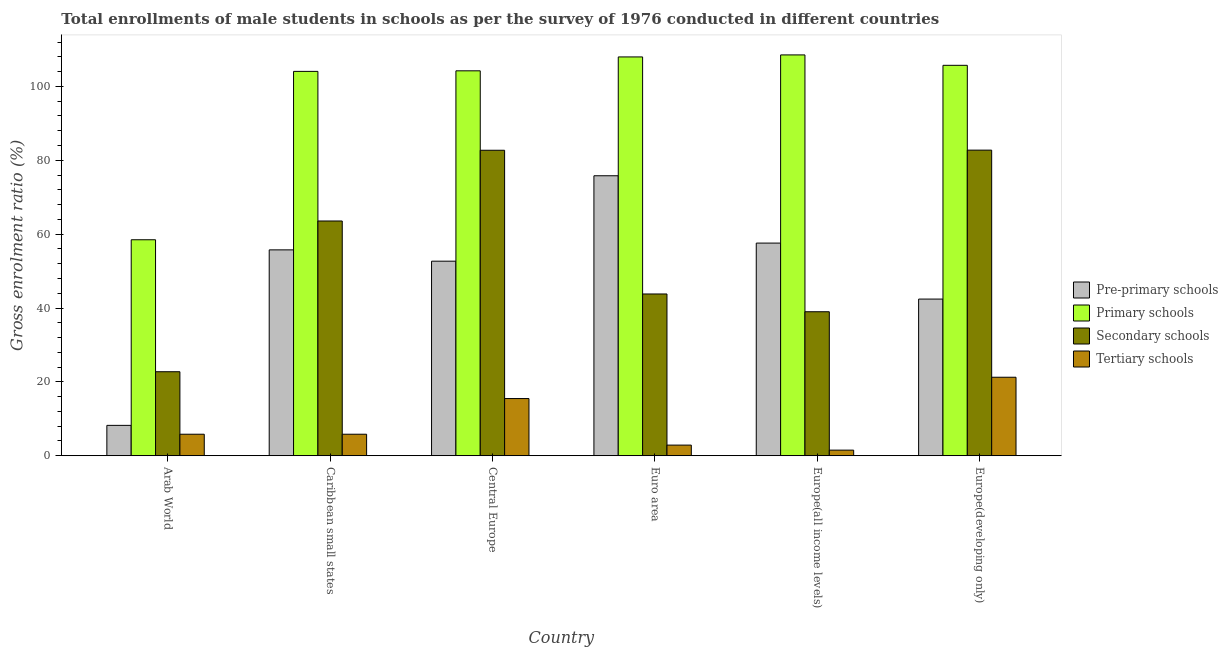How many different coloured bars are there?
Ensure brevity in your answer.  4. Are the number of bars on each tick of the X-axis equal?
Your answer should be compact. Yes. What is the label of the 2nd group of bars from the left?
Provide a succinct answer. Caribbean small states. What is the gross enrolment ratio(male) in pre-primary schools in Europe(all income levels)?
Your answer should be compact. 57.58. Across all countries, what is the maximum gross enrolment ratio(male) in primary schools?
Give a very brief answer. 108.53. Across all countries, what is the minimum gross enrolment ratio(male) in tertiary schools?
Provide a short and direct response. 1.52. In which country was the gross enrolment ratio(male) in pre-primary schools maximum?
Your response must be concise. Euro area. In which country was the gross enrolment ratio(male) in primary schools minimum?
Ensure brevity in your answer.  Arab World. What is the total gross enrolment ratio(male) in tertiary schools in the graph?
Provide a short and direct response. 52.77. What is the difference between the gross enrolment ratio(male) in secondary schools in Caribbean small states and that in Euro area?
Offer a terse response. 19.76. What is the difference between the gross enrolment ratio(male) in secondary schools in Euro area and the gross enrolment ratio(male) in tertiary schools in Europe(all income levels)?
Your answer should be very brief. 42.28. What is the average gross enrolment ratio(male) in pre-primary schools per country?
Your response must be concise. 48.74. What is the difference between the gross enrolment ratio(male) in pre-primary schools and gross enrolment ratio(male) in tertiary schools in Europe(all income levels)?
Keep it short and to the point. 56.06. In how many countries, is the gross enrolment ratio(male) in primary schools greater than 44 %?
Offer a terse response. 6. What is the ratio of the gross enrolment ratio(male) in primary schools in Arab World to that in Caribbean small states?
Provide a short and direct response. 0.56. What is the difference between the highest and the second highest gross enrolment ratio(male) in primary schools?
Give a very brief answer. 0.55. What is the difference between the highest and the lowest gross enrolment ratio(male) in tertiary schools?
Keep it short and to the point. 19.74. In how many countries, is the gross enrolment ratio(male) in pre-primary schools greater than the average gross enrolment ratio(male) in pre-primary schools taken over all countries?
Provide a succinct answer. 4. Is it the case that in every country, the sum of the gross enrolment ratio(male) in secondary schools and gross enrolment ratio(male) in tertiary schools is greater than the sum of gross enrolment ratio(male) in pre-primary schools and gross enrolment ratio(male) in primary schools?
Ensure brevity in your answer.  No. What does the 1st bar from the left in Central Europe represents?
Ensure brevity in your answer.  Pre-primary schools. What does the 3rd bar from the right in Central Europe represents?
Your response must be concise. Primary schools. Is it the case that in every country, the sum of the gross enrolment ratio(male) in pre-primary schools and gross enrolment ratio(male) in primary schools is greater than the gross enrolment ratio(male) in secondary schools?
Offer a terse response. Yes. How many bars are there?
Your answer should be compact. 24. Are all the bars in the graph horizontal?
Offer a terse response. No. How many countries are there in the graph?
Give a very brief answer. 6. Are the values on the major ticks of Y-axis written in scientific E-notation?
Provide a succinct answer. No. Where does the legend appear in the graph?
Ensure brevity in your answer.  Center right. What is the title of the graph?
Offer a terse response. Total enrollments of male students in schools as per the survey of 1976 conducted in different countries. What is the Gross enrolment ratio (%) in Pre-primary schools in Arab World?
Offer a terse response. 8.22. What is the Gross enrolment ratio (%) of Primary schools in Arab World?
Ensure brevity in your answer.  58.48. What is the Gross enrolment ratio (%) of Secondary schools in Arab World?
Provide a short and direct response. 22.75. What is the Gross enrolment ratio (%) in Tertiary schools in Arab World?
Offer a very short reply. 5.82. What is the Gross enrolment ratio (%) of Pre-primary schools in Caribbean small states?
Your answer should be very brief. 55.74. What is the Gross enrolment ratio (%) in Primary schools in Caribbean small states?
Ensure brevity in your answer.  104.08. What is the Gross enrolment ratio (%) in Secondary schools in Caribbean small states?
Provide a succinct answer. 63.56. What is the Gross enrolment ratio (%) of Tertiary schools in Caribbean small states?
Offer a very short reply. 5.82. What is the Gross enrolment ratio (%) of Pre-primary schools in Central Europe?
Provide a succinct answer. 52.68. What is the Gross enrolment ratio (%) in Primary schools in Central Europe?
Your response must be concise. 104.22. What is the Gross enrolment ratio (%) of Secondary schools in Central Europe?
Ensure brevity in your answer.  82.72. What is the Gross enrolment ratio (%) in Tertiary schools in Central Europe?
Keep it short and to the point. 15.48. What is the Gross enrolment ratio (%) of Pre-primary schools in Euro area?
Your answer should be compact. 75.81. What is the Gross enrolment ratio (%) in Primary schools in Euro area?
Ensure brevity in your answer.  107.99. What is the Gross enrolment ratio (%) of Secondary schools in Euro area?
Provide a succinct answer. 43.8. What is the Gross enrolment ratio (%) in Tertiary schools in Euro area?
Offer a terse response. 2.88. What is the Gross enrolment ratio (%) of Pre-primary schools in Europe(all income levels)?
Give a very brief answer. 57.58. What is the Gross enrolment ratio (%) in Primary schools in Europe(all income levels)?
Offer a terse response. 108.53. What is the Gross enrolment ratio (%) of Secondary schools in Europe(all income levels)?
Your answer should be very brief. 38.99. What is the Gross enrolment ratio (%) of Tertiary schools in Europe(all income levels)?
Keep it short and to the point. 1.52. What is the Gross enrolment ratio (%) in Pre-primary schools in Europe(developing only)?
Your response must be concise. 42.42. What is the Gross enrolment ratio (%) of Primary schools in Europe(developing only)?
Ensure brevity in your answer.  105.71. What is the Gross enrolment ratio (%) in Secondary schools in Europe(developing only)?
Ensure brevity in your answer.  82.75. What is the Gross enrolment ratio (%) of Tertiary schools in Europe(developing only)?
Keep it short and to the point. 21.25. Across all countries, what is the maximum Gross enrolment ratio (%) of Pre-primary schools?
Keep it short and to the point. 75.81. Across all countries, what is the maximum Gross enrolment ratio (%) of Primary schools?
Your response must be concise. 108.53. Across all countries, what is the maximum Gross enrolment ratio (%) in Secondary schools?
Offer a terse response. 82.75. Across all countries, what is the maximum Gross enrolment ratio (%) of Tertiary schools?
Provide a succinct answer. 21.25. Across all countries, what is the minimum Gross enrolment ratio (%) in Pre-primary schools?
Your answer should be compact. 8.22. Across all countries, what is the minimum Gross enrolment ratio (%) in Primary schools?
Provide a short and direct response. 58.48. Across all countries, what is the minimum Gross enrolment ratio (%) in Secondary schools?
Keep it short and to the point. 22.75. Across all countries, what is the minimum Gross enrolment ratio (%) in Tertiary schools?
Give a very brief answer. 1.52. What is the total Gross enrolment ratio (%) of Pre-primary schools in the graph?
Keep it short and to the point. 292.46. What is the total Gross enrolment ratio (%) in Primary schools in the graph?
Ensure brevity in your answer.  589.02. What is the total Gross enrolment ratio (%) of Secondary schools in the graph?
Your response must be concise. 334.56. What is the total Gross enrolment ratio (%) in Tertiary schools in the graph?
Give a very brief answer. 52.77. What is the difference between the Gross enrolment ratio (%) of Pre-primary schools in Arab World and that in Caribbean small states?
Make the answer very short. -47.52. What is the difference between the Gross enrolment ratio (%) of Primary schools in Arab World and that in Caribbean small states?
Offer a terse response. -45.59. What is the difference between the Gross enrolment ratio (%) of Secondary schools in Arab World and that in Caribbean small states?
Offer a terse response. -40.82. What is the difference between the Gross enrolment ratio (%) in Tertiary schools in Arab World and that in Caribbean small states?
Ensure brevity in your answer.  -0. What is the difference between the Gross enrolment ratio (%) of Pre-primary schools in Arab World and that in Central Europe?
Offer a very short reply. -44.46. What is the difference between the Gross enrolment ratio (%) of Primary schools in Arab World and that in Central Europe?
Make the answer very short. -45.74. What is the difference between the Gross enrolment ratio (%) of Secondary schools in Arab World and that in Central Europe?
Your response must be concise. -59.97. What is the difference between the Gross enrolment ratio (%) in Tertiary schools in Arab World and that in Central Europe?
Offer a very short reply. -9.66. What is the difference between the Gross enrolment ratio (%) in Pre-primary schools in Arab World and that in Euro area?
Ensure brevity in your answer.  -67.59. What is the difference between the Gross enrolment ratio (%) in Primary schools in Arab World and that in Euro area?
Your answer should be very brief. -49.5. What is the difference between the Gross enrolment ratio (%) of Secondary schools in Arab World and that in Euro area?
Your answer should be very brief. -21.05. What is the difference between the Gross enrolment ratio (%) in Tertiary schools in Arab World and that in Euro area?
Provide a succinct answer. 2.95. What is the difference between the Gross enrolment ratio (%) of Pre-primary schools in Arab World and that in Europe(all income levels)?
Give a very brief answer. -49.36. What is the difference between the Gross enrolment ratio (%) in Primary schools in Arab World and that in Europe(all income levels)?
Make the answer very short. -50.05. What is the difference between the Gross enrolment ratio (%) in Secondary schools in Arab World and that in Europe(all income levels)?
Ensure brevity in your answer.  -16.24. What is the difference between the Gross enrolment ratio (%) in Tertiary schools in Arab World and that in Europe(all income levels)?
Keep it short and to the point. 4.31. What is the difference between the Gross enrolment ratio (%) of Pre-primary schools in Arab World and that in Europe(developing only)?
Your response must be concise. -34.2. What is the difference between the Gross enrolment ratio (%) in Primary schools in Arab World and that in Europe(developing only)?
Give a very brief answer. -47.23. What is the difference between the Gross enrolment ratio (%) in Secondary schools in Arab World and that in Europe(developing only)?
Give a very brief answer. -60. What is the difference between the Gross enrolment ratio (%) of Tertiary schools in Arab World and that in Europe(developing only)?
Your answer should be very brief. -15.43. What is the difference between the Gross enrolment ratio (%) of Pre-primary schools in Caribbean small states and that in Central Europe?
Ensure brevity in your answer.  3.06. What is the difference between the Gross enrolment ratio (%) in Primary schools in Caribbean small states and that in Central Europe?
Provide a short and direct response. -0.15. What is the difference between the Gross enrolment ratio (%) in Secondary schools in Caribbean small states and that in Central Europe?
Provide a short and direct response. -19.15. What is the difference between the Gross enrolment ratio (%) in Tertiary schools in Caribbean small states and that in Central Europe?
Offer a very short reply. -9.66. What is the difference between the Gross enrolment ratio (%) of Pre-primary schools in Caribbean small states and that in Euro area?
Offer a very short reply. -20.07. What is the difference between the Gross enrolment ratio (%) of Primary schools in Caribbean small states and that in Euro area?
Your answer should be compact. -3.91. What is the difference between the Gross enrolment ratio (%) of Secondary schools in Caribbean small states and that in Euro area?
Ensure brevity in your answer.  19.76. What is the difference between the Gross enrolment ratio (%) of Tertiary schools in Caribbean small states and that in Euro area?
Offer a terse response. 2.95. What is the difference between the Gross enrolment ratio (%) in Pre-primary schools in Caribbean small states and that in Europe(all income levels)?
Give a very brief answer. -1.84. What is the difference between the Gross enrolment ratio (%) in Primary schools in Caribbean small states and that in Europe(all income levels)?
Make the answer very short. -4.46. What is the difference between the Gross enrolment ratio (%) in Secondary schools in Caribbean small states and that in Europe(all income levels)?
Give a very brief answer. 24.58. What is the difference between the Gross enrolment ratio (%) in Tertiary schools in Caribbean small states and that in Europe(all income levels)?
Offer a terse response. 4.31. What is the difference between the Gross enrolment ratio (%) in Pre-primary schools in Caribbean small states and that in Europe(developing only)?
Keep it short and to the point. 13.32. What is the difference between the Gross enrolment ratio (%) in Primary schools in Caribbean small states and that in Europe(developing only)?
Make the answer very short. -1.64. What is the difference between the Gross enrolment ratio (%) of Secondary schools in Caribbean small states and that in Europe(developing only)?
Offer a very short reply. -19.18. What is the difference between the Gross enrolment ratio (%) of Tertiary schools in Caribbean small states and that in Europe(developing only)?
Your answer should be very brief. -15.43. What is the difference between the Gross enrolment ratio (%) in Pre-primary schools in Central Europe and that in Euro area?
Ensure brevity in your answer.  -23.13. What is the difference between the Gross enrolment ratio (%) of Primary schools in Central Europe and that in Euro area?
Make the answer very short. -3.76. What is the difference between the Gross enrolment ratio (%) of Secondary schools in Central Europe and that in Euro area?
Offer a very short reply. 38.92. What is the difference between the Gross enrolment ratio (%) of Tertiary schools in Central Europe and that in Euro area?
Offer a terse response. 12.61. What is the difference between the Gross enrolment ratio (%) in Pre-primary schools in Central Europe and that in Europe(all income levels)?
Give a very brief answer. -4.9. What is the difference between the Gross enrolment ratio (%) of Primary schools in Central Europe and that in Europe(all income levels)?
Provide a short and direct response. -4.31. What is the difference between the Gross enrolment ratio (%) of Secondary schools in Central Europe and that in Europe(all income levels)?
Give a very brief answer. 43.73. What is the difference between the Gross enrolment ratio (%) of Tertiary schools in Central Europe and that in Europe(all income levels)?
Provide a short and direct response. 13.97. What is the difference between the Gross enrolment ratio (%) in Pre-primary schools in Central Europe and that in Europe(developing only)?
Give a very brief answer. 10.26. What is the difference between the Gross enrolment ratio (%) of Primary schools in Central Europe and that in Europe(developing only)?
Offer a terse response. -1.49. What is the difference between the Gross enrolment ratio (%) of Secondary schools in Central Europe and that in Europe(developing only)?
Make the answer very short. -0.03. What is the difference between the Gross enrolment ratio (%) in Tertiary schools in Central Europe and that in Europe(developing only)?
Make the answer very short. -5.77. What is the difference between the Gross enrolment ratio (%) in Pre-primary schools in Euro area and that in Europe(all income levels)?
Keep it short and to the point. 18.23. What is the difference between the Gross enrolment ratio (%) in Primary schools in Euro area and that in Europe(all income levels)?
Offer a very short reply. -0.55. What is the difference between the Gross enrolment ratio (%) of Secondary schools in Euro area and that in Europe(all income levels)?
Make the answer very short. 4.81. What is the difference between the Gross enrolment ratio (%) in Tertiary schools in Euro area and that in Europe(all income levels)?
Make the answer very short. 1.36. What is the difference between the Gross enrolment ratio (%) of Pre-primary schools in Euro area and that in Europe(developing only)?
Keep it short and to the point. 33.39. What is the difference between the Gross enrolment ratio (%) of Primary schools in Euro area and that in Europe(developing only)?
Your answer should be very brief. 2.27. What is the difference between the Gross enrolment ratio (%) of Secondary schools in Euro area and that in Europe(developing only)?
Give a very brief answer. -38.95. What is the difference between the Gross enrolment ratio (%) in Tertiary schools in Euro area and that in Europe(developing only)?
Provide a succinct answer. -18.38. What is the difference between the Gross enrolment ratio (%) of Pre-primary schools in Europe(all income levels) and that in Europe(developing only)?
Give a very brief answer. 15.16. What is the difference between the Gross enrolment ratio (%) in Primary schools in Europe(all income levels) and that in Europe(developing only)?
Ensure brevity in your answer.  2.82. What is the difference between the Gross enrolment ratio (%) in Secondary schools in Europe(all income levels) and that in Europe(developing only)?
Your answer should be compact. -43.76. What is the difference between the Gross enrolment ratio (%) in Tertiary schools in Europe(all income levels) and that in Europe(developing only)?
Your answer should be very brief. -19.74. What is the difference between the Gross enrolment ratio (%) of Pre-primary schools in Arab World and the Gross enrolment ratio (%) of Primary schools in Caribbean small states?
Provide a succinct answer. -95.85. What is the difference between the Gross enrolment ratio (%) in Pre-primary schools in Arab World and the Gross enrolment ratio (%) in Secondary schools in Caribbean small states?
Provide a succinct answer. -55.34. What is the difference between the Gross enrolment ratio (%) in Pre-primary schools in Arab World and the Gross enrolment ratio (%) in Tertiary schools in Caribbean small states?
Make the answer very short. 2.4. What is the difference between the Gross enrolment ratio (%) of Primary schools in Arab World and the Gross enrolment ratio (%) of Secondary schools in Caribbean small states?
Keep it short and to the point. -5.08. What is the difference between the Gross enrolment ratio (%) in Primary schools in Arab World and the Gross enrolment ratio (%) in Tertiary schools in Caribbean small states?
Your response must be concise. 52.66. What is the difference between the Gross enrolment ratio (%) in Secondary schools in Arab World and the Gross enrolment ratio (%) in Tertiary schools in Caribbean small states?
Your answer should be very brief. 16.92. What is the difference between the Gross enrolment ratio (%) of Pre-primary schools in Arab World and the Gross enrolment ratio (%) of Primary schools in Central Europe?
Offer a terse response. -96. What is the difference between the Gross enrolment ratio (%) of Pre-primary schools in Arab World and the Gross enrolment ratio (%) of Secondary schools in Central Europe?
Offer a very short reply. -74.49. What is the difference between the Gross enrolment ratio (%) of Pre-primary schools in Arab World and the Gross enrolment ratio (%) of Tertiary schools in Central Europe?
Offer a very short reply. -7.26. What is the difference between the Gross enrolment ratio (%) of Primary schools in Arab World and the Gross enrolment ratio (%) of Secondary schools in Central Europe?
Your response must be concise. -24.23. What is the difference between the Gross enrolment ratio (%) in Primary schools in Arab World and the Gross enrolment ratio (%) in Tertiary schools in Central Europe?
Ensure brevity in your answer.  43. What is the difference between the Gross enrolment ratio (%) in Secondary schools in Arab World and the Gross enrolment ratio (%) in Tertiary schools in Central Europe?
Your answer should be compact. 7.26. What is the difference between the Gross enrolment ratio (%) of Pre-primary schools in Arab World and the Gross enrolment ratio (%) of Primary schools in Euro area?
Your answer should be very brief. -99.77. What is the difference between the Gross enrolment ratio (%) in Pre-primary schools in Arab World and the Gross enrolment ratio (%) in Secondary schools in Euro area?
Provide a succinct answer. -35.58. What is the difference between the Gross enrolment ratio (%) in Pre-primary schools in Arab World and the Gross enrolment ratio (%) in Tertiary schools in Euro area?
Offer a terse response. 5.35. What is the difference between the Gross enrolment ratio (%) of Primary schools in Arab World and the Gross enrolment ratio (%) of Secondary schools in Euro area?
Your answer should be compact. 14.68. What is the difference between the Gross enrolment ratio (%) of Primary schools in Arab World and the Gross enrolment ratio (%) of Tertiary schools in Euro area?
Your answer should be very brief. 55.61. What is the difference between the Gross enrolment ratio (%) of Secondary schools in Arab World and the Gross enrolment ratio (%) of Tertiary schools in Euro area?
Offer a terse response. 19.87. What is the difference between the Gross enrolment ratio (%) in Pre-primary schools in Arab World and the Gross enrolment ratio (%) in Primary schools in Europe(all income levels)?
Ensure brevity in your answer.  -100.31. What is the difference between the Gross enrolment ratio (%) in Pre-primary schools in Arab World and the Gross enrolment ratio (%) in Secondary schools in Europe(all income levels)?
Your response must be concise. -30.77. What is the difference between the Gross enrolment ratio (%) of Pre-primary schools in Arab World and the Gross enrolment ratio (%) of Tertiary schools in Europe(all income levels)?
Your answer should be compact. 6.71. What is the difference between the Gross enrolment ratio (%) in Primary schools in Arab World and the Gross enrolment ratio (%) in Secondary schools in Europe(all income levels)?
Ensure brevity in your answer.  19.5. What is the difference between the Gross enrolment ratio (%) of Primary schools in Arab World and the Gross enrolment ratio (%) of Tertiary schools in Europe(all income levels)?
Give a very brief answer. 56.97. What is the difference between the Gross enrolment ratio (%) of Secondary schools in Arab World and the Gross enrolment ratio (%) of Tertiary schools in Europe(all income levels)?
Keep it short and to the point. 21.23. What is the difference between the Gross enrolment ratio (%) in Pre-primary schools in Arab World and the Gross enrolment ratio (%) in Primary schools in Europe(developing only)?
Provide a short and direct response. -97.49. What is the difference between the Gross enrolment ratio (%) in Pre-primary schools in Arab World and the Gross enrolment ratio (%) in Secondary schools in Europe(developing only)?
Your response must be concise. -74.53. What is the difference between the Gross enrolment ratio (%) in Pre-primary schools in Arab World and the Gross enrolment ratio (%) in Tertiary schools in Europe(developing only)?
Your answer should be compact. -13.03. What is the difference between the Gross enrolment ratio (%) in Primary schools in Arab World and the Gross enrolment ratio (%) in Secondary schools in Europe(developing only)?
Offer a very short reply. -24.27. What is the difference between the Gross enrolment ratio (%) of Primary schools in Arab World and the Gross enrolment ratio (%) of Tertiary schools in Europe(developing only)?
Provide a short and direct response. 37.23. What is the difference between the Gross enrolment ratio (%) in Secondary schools in Arab World and the Gross enrolment ratio (%) in Tertiary schools in Europe(developing only)?
Keep it short and to the point. 1.49. What is the difference between the Gross enrolment ratio (%) of Pre-primary schools in Caribbean small states and the Gross enrolment ratio (%) of Primary schools in Central Europe?
Keep it short and to the point. -48.48. What is the difference between the Gross enrolment ratio (%) in Pre-primary schools in Caribbean small states and the Gross enrolment ratio (%) in Secondary schools in Central Europe?
Make the answer very short. -26.97. What is the difference between the Gross enrolment ratio (%) in Pre-primary schools in Caribbean small states and the Gross enrolment ratio (%) in Tertiary schools in Central Europe?
Provide a succinct answer. 40.26. What is the difference between the Gross enrolment ratio (%) of Primary schools in Caribbean small states and the Gross enrolment ratio (%) of Secondary schools in Central Europe?
Ensure brevity in your answer.  21.36. What is the difference between the Gross enrolment ratio (%) of Primary schools in Caribbean small states and the Gross enrolment ratio (%) of Tertiary schools in Central Europe?
Offer a very short reply. 88.59. What is the difference between the Gross enrolment ratio (%) in Secondary schools in Caribbean small states and the Gross enrolment ratio (%) in Tertiary schools in Central Europe?
Provide a short and direct response. 48.08. What is the difference between the Gross enrolment ratio (%) of Pre-primary schools in Caribbean small states and the Gross enrolment ratio (%) of Primary schools in Euro area?
Make the answer very short. -52.24. What is the difference between the Gross enrolment ratio (%) in Pre-primary schools in Caribbean small states and the Gross enrolment ratio (%) in Secondary schools in Euro area?
Provide a short and direct response. 11.94. What is the difference between the Gross enrolment ratio (%) in Pre-primary schools in Caribbean small states and the Gross enrolment ratio (%) in Tertiary schools in Euro area?
Offer a terse response. 52.87. What is the difference between the Gross enrolment ratio (%) in Primary schools in Caribbean small states and the Gross enrolment ratio (%) in Secondary schools in Euro area?
Ensure brevity in your answer.  60.28. What is the difference between the Gross enrolment ratio (%) in Primary schools in Caribbean small states and the Gross enrolment ratio (%) in Tertiary schools in Euro area?
Your response must be concise. 101.2. What is the difference between the Gross enrolment ratio (%) in Secondary schools in Caribbean small states and the Gross enrolment ratio (%) in Tertiary schools in Euro area?
Keep it short and to the point. 60.69. What is the difference between the Gross enrolment ratio (%) of Pre-primary schools in Caribbean small states and the Gross enrolment ratio (%) of Primary schools in Europe(all income levels)?
Offer a terse response. -52.79. What is the difference between the Gross enrolment ratio (%) in Pre-primary schools in Caribbean small states and the Gross enrolment ratio (%) in Secondary schools in Europe(all income levels)?
Keep it short and to the point. 16.76. What is the difference between the Gross enrolment ratio (%) of Pre-primary schools in Caribbean small states and the Gross enrolment ratio (%) of Tertiary schools in Europe(all income levels)?
Ensure brevity in your answer.  54.23. What is the difference between the Gross enrolment ratio (%) of Primary schools in Caribbean small states and the Gross enrolment ratio (%) of Secondary schools in Europe(all income levels)?
Provide a short and direct response. 65.09. What is the difference between the Gross enrolment ratio (%) of Primary schools in Caribbean small states and the Gross enrolment ratio (%) of Tertiary schools in Europe(all income levels)?
Provide a short and direct response. 102.56. What is the difference between the Gross enrolment ratio (%) in Secondary schools in Caribbean small states and the Gross enrolment ratio (%) in Tertiary schools in Europe(all income levels)?
Your answer should be compact. 62.05. What is the difference between the Gross enrolment ratio (%) of Pre-primary schools in Caribbean small states and the Gross enrolment ratio (%) of Primary schools in Europe(developing only)?
Give a very brief answer. -49.97. What is the difference between the Gross enrolment ratio (%) in Pre-primary schools in Caribbean small states and the Gross enrolment ratio (%) in Secondary schools in Europe(developing only)?
Your answer should be very brief. -27.01. What is the difference between the Gross enrolment ratio (%) in Pre-primary schools in Caribbean small states and the Gross enrolment ratio (%) in Tertiary schools in Europe(developing only)?
Keep it short and to the point. 34.49. What is the difference between the Gross enrolment ratio (%) in Primary schools in Caribbean small states and the Gross enrolment ratio (%) in Secondary schools in Europe(developing only)?
Your answer should be very brief. 21.33. What is the difference between the Gross enrolment ratio (%) in Primary schools in Caribbean small states and the Gross enrolment ratio (%) in Tertiary schools in Europe(developing only)?
Provide a short and direct response. 82.82. What is the difference between the Gross enrolment ratio (%) in Secondary schools in Caribbean small states and the Gross enrolment ratio (%) in Tertiary schools in Europe(developing only)?
Offer a very short reply. 42.31. What is the difference between the Gross enrolment ratio (%) in Pre-primary schools in Central Europe and the Gross enrolment ratio (%) in Primary schools in Euro area?
Give a very brief answer. -55.31. What is the difference between the Gross enrolment ratio (%) of Pre-primary schools in Central Europe and the Gross enrolment ratio (%) of Secondary schools in Euro area?
Offer a very short reply. 8.88. What is the difference between the Gross enrolment ratio (%) in Pre-primary schools in Central Europe and the Gross enrolment ratio (%) in Tertiary schools in Euro area?
Ensure brevity in your answer.  49.8. What is the difference between the Gross enrolment ratio (%) of Primary schools in Central Europe and the Gross enrolment ratio (%) of Secondary schools in Euro area?
Give a very brief answer. 60.42. What is the difference between the Gross enrolment ratio (%) in Primary schools in Central Europe and the Gross enrolment ratio (%) in Tertiary schools in Euro area?
Keep it short and to the point. 101.35. What is the difference between the Gross enrolment ratio (%) of Secondary schools in Central Europe and the Gross enrolment ratio (%) of Tertiary schools in Euro area?
Keep it short and to the point. 79.84. What is the difference between the Gross enrolment ratio (%) in Pre-primary schools in Central Europe and the Gross enrolment ratio (%) in Primary schools in Europe(all income levels)?
Your answer should be compact. -55.85. What is the difference between the Gross enrolment ratio (%) in Pre-primary schools in Central Europe and the Gross enrolment ratio (%) in Secondary schools in Europe(all income levels)?
Make the answer very short. 13.69. What is the difference between the Gross enrolment ratio (%) in Pre-primary schools in Central Europe and the Gross enrolment ratio (%) in Tertiary schools in Europe(all income levels)?
Offer a terse response. 51.16. What is the difference between the Gross enrolment ratio (%) of Primary schools in Central Europe and the Gross enrolment ratio (%) of Secondary schools in Europe(all income levels)?
Provide a succinct answer. 65.24. What is the difference between the Gross enrolment ratio (%) of Primary schools in Central Europe and the Gross enrolment ratio (%) of Tertiary schools in Europe(all income levels)?
Give a very brief answer. 102.71. What is the difference between the Gross enrolment ratio (%) of Secondary schools in Central Europe and the Gross enrolment ratio (%) of Tertiary schools in Europe(all income levels)?
Offer a terse response. 81.2. What is the difference between the Gross enrolment ratio (%) in Pre-primary schools in Central Europe and the Gross enrolment ratio (%) in Primary schools in Europe(developing only)?
Provide a short and direct response. -53.03. What is the difference between the Gross enrolment ratio (%) of Pre-primary schools in Central Europe and the Gross enrolment ratio (%) of Secondary schools in Europe(developing only)?
Provide a succinct answer. -30.07. What is the difference between the Gross enrolment ratio (%) of Pre-primary schools in Central Europe and the Gross enrolment ratio (%) of Tertiary schools in Europe(developing only)?
Your response must be concise. 31.43. What is the difference between the Gross enrolment ratio (%) of Primary schools in Central Europe and the Gross enrolment ratio (%) of Secondary schools in Europe(developing only)?
Your response must be concise. 21.48. What is the difference between the Gross enrolment ratio (%) of Primary schools in Central Europe and the Gross enrolment ratio (%) of Tertiary schools in Europe(developing only)?
Provide a succinct answer. 82.97. What is the difference between the Gross enrolment ratio (%) of Secondary schools in Central Europe and the Gross enrolment ratio (%) of Tertiary schools in Europe(developing only)?
Keep it short and to the point. 61.46. What is the difference between the Gross enrolment ratio (%) of Pre-primary schools in Euro area and the Gross enrolment ratio (%) of Primary schools in Europe(all income levels)?
Give a very brief answer. -32.72. What is the difference between the Gross enrolment ratio (%) in Pre-primary schools in Euro area and the Gross enrolment ratio (%) in Secondary schools in Europe(all income levels)?
Ensure brevity in your answer.  36.82. What is the difference between the Gross enrolment ratio (%) in Pre-primary schools in Euro area and the Gross enrolment ratio (%) in Tertiary schools in Europe(all income levels)?
Keep it short and to the point. 74.29. What is the difference between the Gross enrolment ratio (%) in Primary schools in Euro area and the Gross enrolment ratio (%) in Secondary schools in Europe(all income levels)?
Your response must be concise. 69. What is the difference between the Gross enrolment ratio (%) of Primary schools in Euro area and the Gross enrolment ratio (%) of Tertiary schools in Europe(all income levels)?
Your answer should be compact. 106.47. What is the difference between the Gross enrolment ratio (%) in Secondary schools in Euro area and the Gross enrolment ratio (%) in Tertiary schools in Europe(all income levels)?
Provide a succinct answer. 42.28. What is the difference between the Gross enrolment ratio (%) in Pre-primary schools in Euro area and the Gross enrolment ratio (%) in Primary schools in Europe(developing only)?
Offer a very short reply. -29.9. What is the difference between the Gross enrolment ratio (%) of Pre-primary schools in Euro area and the Gross enrolment ratio (%) of Secondary schools in Europe(developing only)?
Offer a terse response. -6.94. What is the difference between the Gross enrolment ratio (%) of Pre-primary schools in Euro area and the Gross enrolment ratio (%) of Tertiary schools in Europe(developing only)?
Keep it short and to the point. 54.56. What is the difference between the Gross enrolment ratio (%) in Primary schools in Euro area and the Gross enrolment ratio (%) in Secondary schools in Europe(developing only)?
Provide a short and direct response. 25.24. What is the difference between the Gross enrolment ratio (%) in Primary schools in Euro area and the Gross enrolment ratio (%) in Tertiary schools in Europe(developing only)?
Your answer should be compact. 86.73. What is the difference between the Gross enrolment ratio (%) of Secondary schools in Euro area and the Gross enrolment ratio (%) of Tertiary schools in Europe(developing only)?
Your answer should be very brief. 22.55. What is the difference between the Gross enrolment ratio (%) in Pre-primary schools in Europe(all income levels) and the Gross enrolment ratio (%) in Primary schools in Europe(developing only)?
Keep it short and to the point. -48.13. What is the difference between the Gross enrolment ratio (%) of Pre-primary schools in Europe(all income levels) and the Gross enrolment ratio (%) of Secondary schools in Europe(developing only)?
Provide a short and direct response. -25.17. What is the difference between the Gross enrolment ratio (%) of Pre-primary schools in Europe(all income levels) and the Gross enrolment ratio (%) of Tertiary schools in Europe(developing only)?
Give a very brief answer. 36.33. What is the difference between the Gross enrolment ratio (%) of Primary schools in Europe(all income levels) and the Gross enrolment ratio (%) of Secondary schools in Europe(developing only)?
Offer a terse response. 25.78. What is the difference between the Gross enrolment ratio (%) of Primary schools in Europe(all income levels) and the Gross enrolment ratio (%) of Tertiary schools in Europe(developing only)?
Keep it short and to the point. 87.28. What is the difference between the Gross enrolment ratio (%) in Secondary schools in Europe(all income levels) and the Gross enrolment ratio (%) in Tertiary schools in Europe(developing only)?
Keep it short and to the point. 17.73. What is the average Gross enrolment ratio (%) in Pre-primary schools per country?
Provide a succinct answer. 48.74. What is the average Gross enrolment ratio (%) in Primary schools per country?
Keep it short and to the point. 98.17. What is the average Gross enrolment ratio (%) of Secondary schools per country?
Give a very brief answer. 55.76. What is the average Gross enrolment ratio (%) in Tertiary schools per country?
Offer a very short reply. 8.8. What is the difference between the Gross enrolment ratio (%) of Pre-primary schools and Gross enrolment ratio (%) of Primary schools in Arab World?
Your answer should be compact. -50.26. What is the difference between the Gross enrolment ratio (%) in Pre-primary schools and Gross enrolment ratio (%) in Secondary schools in Arab World?
Provide a succinct answer. -14.52. What is the difference between the Gross enrolment ratio (%) of Pre-primary schools and Gross enrolment ratio (%) of Tertiary schools in Arab World?
Give a very brief answer. 2.4. What is the difference between the Gross enrolment ratio (%) in Primary schools and Gross enrolment ratio (%) in Secondary schools in Arab World?
Provide a short and direct response. 35.74. What is the difference between the Gross enrolment ratio (%) in Primary schools and Gross enrolment ratio (%) in Tertiary schools in Arab World?
Offer a very short reply. 52.66. What is the difference between the Gross enrolment ratio (%) in Secondary schools and Gross enrolment ratio (%) in Tertiary schools in Arab World?
Ensure brevity in your answer.  16.92. What is the difference between the Gross enrolment ratio (%) of Pre-primary schools and Gross enrolment ratio (%) of Primary schools in Caribbean small states?
Provide a succinct answer. -48.33. What is the difference between the Gross enrolment ratio (%) of Pre-primary schools and Gross enrolment ratio (%) of Secondary schools in Caribbean small states?
Give a very brief answer. -7.82. What is the difference between the Gross enrolment ratio (%) in Pre-primary schools and Gross enrolment ratio (%) in Tertiary schools in Caribbean small states?
Your response must be concise. 49.92. What is the difference between the Gross enrolment ratio (%) in Primary schools and Gross enrolment ratio (%) in Secondary schools in Caribbean small states?
Your response must be concise. 40.51. What is the difference between the Gross enrolment ratio (%) in Primary schools and Gross enrolment ratio (%) in Tertiary schools in Caribbean small states?
Ensure brevity in your answer.  98.25. What is the difference between the Gross enrolment ratio (%) in Secondary schools and Gross enrolment ratio (%) in Tertiary schools in Caribbean small states?
Give a very brief answer. 57.74. What is the difference between the Gross enrolment ratio (%) of Pre-primary schools and Gross enrolment ratio (%) of Primary schools in Central Europe?
Keep it short and to the point. -51.55. What is the difference between the Gross enrolment ratio (%) of Pre-primary schools and Gross enrolment ratio (%) of Secondary schools in Central Europe?
Your answer should be very brief. -30.04. What is the difference between the Gross enrolment ratio (%) in Pre-primary schools and Gross enrolment ratio (%) in Tertiary schools in Central Europe?
Your response must be concise. 37.2. What is the difference between the Gross enrolment ratio (%) in Primary schools and Gross enrolment ratio (%) in Secondary schools in Central Europe?
Provide a succinct answer. 21.51. What is the difference between the Gross enrolment ratio (%) of Primary schools and Gross enrolment ratio (%) of Tertiary schools in Central Europe?
Your response must be concise. 88.74. What is the difference between the Gross enrolment ratio (%) of Secondary schools and Gross enrolment ratio (%) of Tertiary schools in Central Europe?
Give a very brief answer. 67.23. What is the difference between the Gross enrolment ratio (%) of Pre-primary schools and Gross enrolment ratio (%) of Primary schools in Euro area?
Your answer should be compact. -32.18. What is the difference between the Gross enrolment ratio (%) of Pre-primary schools and Gross enrolment ratio (%) of Secondary schools in Euro area?
Your answer should be compact. 32.01. What is the difference between the Gross enrolment ratio (%) of Pre-primary schools and Gross enrolment ratio (%) of Tertiary schools in Euro area?
Ensure brevity in your answer.  72.93. What is the difference between the Gross enrolment ratio (%) in Primary schools and Gross enrolment ratio (%) in Secondary schools in Euro area?
Offer a terse response. 64.19. What is the difference between the Gross enrolment ratio (%) of Primary schools and Gross enrolment ratio (%) of Tertiary schools in Euro area?
Ensure brevity in your answer.  105.11. What is the difference between the Gross enrolment ratio (%) of Secondary schools and Gross enrolment ratio (%) of Tertiary schools in Euro area?
Ensure brevity in your answer.  40.92. What is the difference between the Gross enrolment ratio (%) of Pre-primary schools and Gross enrolment ratio (%) of Primary schools in Europe(all income levels)?
Your answer should be very brief. -50.95. What is the difference between the Gross enrolment ratio (%) of Pre-primary schools and Gross enrolment ratio (%) of Secondary schools in Europe(all income levels)?
Ensure brevity in your answer.  18.59. What is the difference between the Gross enrolment ratio (%) of Pre-primary schools and Gross enrolment ratio (%) of Tertiary schools in Europe(all income levels)?
Your response must be concise. 56.06. What is the difference between the Gross enrolment ratio (%) in Primary schools and Gross enrolment ratio (%) in Secondary schools in Europe(all income levels)?
Your answer should be compact. 69.55. What is the difference between the Gross enrolment ratio (%) in Primary schools and Gross enrolment ratio (%) in Tertiary schools in Europe(all income levels)?
Provide a succinct answer. 107.02. What is the difference between the Gross enrolment ratio (%) of Secondary schools and Gross enrolment ratio (%) of Tertiary schools in Europe(all income levels)?
Give a very brief answer. 37.47. What is the difference between the Gross enrolment ratio (%) of Pre-primary schools and Gross enrolment ratio (%) of Primary schools in Europe(developing only)?
Provide a short and direct response. -63.29. What is the difference between the Gross enrolment ratio (%) of Pre-primary schools and Gross enrolment ratio (%) of Secondary schools in Europe(developing only)?
Your answer should be compact. -40.33. What is the difference between the Gross enrolment ratio (%) in Pre-primary schools and Gross enrolment ratio (%) in Tertiary schools in Europe(developing only)?
Make the answer very short. 21.17. What is the difference between the Gross enrolment ratio (%) of Primary schools and Gross enrolment ratio (%) of Secondary schools in Europe(developing only)?
Your answer should be compact. 22.97. What is the difference between the Gross enrolment ratio (%) in Primary schools and Gross enrolment ratio (%) in Tertiary schools in Europe(developing only)?
Offer a very short reply. 84.46. What is the difference between the Gross enrolment ratio (%) of Secondary schools and Gross enrolment ratio (%) of Tertiary schools in Europe(developing only)?
Offer a terse response. 61.5. What is the ratio of the Gross enrolment ratio (%) of Pre-primary schools in Arab World to that in Caribbean small states?
Your response must be concise. 0.15. What is the ratio of the Gross enrolment ratio (%) of Primary schools in Arab World to that in Caribbean small states?
Provide a succinct answer. 0.56. What is the ratio of the Gross enrolment ratio (%) in Secondary schools in Arab World to that in Caribbean small states?
Provide a short and direct response. 0.36. What is the ratio of the Gross enrolment ratio (%) in Tertiary schools in Arab World to that in Caribbean small states?
Provide a succinct answer. 1. What is the ratio of the Gross enrolment ratio (%) in Pre-primary schools in Arab World to that in Central Europe?
Offer a very short reply. 0.16. What is the ratio of the Gross enrolment ratio (%) in Primary schools in Arab World to that in Central Europe?
Make the answer very short. 0.56. What is the ratio of the Gross enrolment ratio (%) of Secondary schools in Arab World to that in Central Europe?
Provide a succinct answer. 0.28. What is the ratio of the Gross enrolment ratio (%) of Tertiary schools in Arab World to that in Central Europe?
Keep it short and to the point. 0.38. What is the ratio of the Gross enrolment ratio (%) of Pre-primary schools in Arab World to that in Euro area?
Give a very brief answer. 0.11. What is the ratio of the Gross enrolment ratio (%) of Primary schools in Arab World to that in Euro area?
Give a very brief answer. 0.54. What is the ratio of the Gross enrolment ratio (%) of Secondary schools in Arab World to that in Euro area?
Give a very brief answer. 0.52. What is the ratio of the Gross enrolment ratio (%) in Tertiary schools in Arab World to that in Euro area?
Make the answer very short. 2.02. What is the ratio of the Gross enrolment ratio (%) in Pre-primary schools in Arab World to that in Europe(all income levels)?
Keep it short and to the point. 0.14. What is the ratio of the Gross enrolment ratio (%) of Primary schools in Arab World to that in Europe(all income levels)?
Your response must be concise. 0.54. What is the ratio of the Gross enrolment ratio (%) of Secondary schools in Arab World to that in Europe(all income levels)?
Your response must be concise. 0.58. What is the ratio of the Gross enrolment ratio (%) in Tertiary schools in Arab World to that in Europe(all income levels)?
Your answer should be very brief. 3.84. What is the ratio of the Gross enrolment ratio (%) in Pre-primary schools in Arab World to that in Europe(developing only)?
Your answer should be very brief. 0.19. What is the ratio of the Gross enrolment ratio (%) in Primary schools in Arab World to that in Europe(developing only)?
Your response must be concise. 0.55. What is the ratio of the Gross enrolment ratio (%) of Secondary schools in Arab World to that in Europe(developing only)?
Keep it short and to the point. 0.27. What is the ratio of the Gross enrolment ratio (%) in Tertiary schools in Arab World to that in Europe(developing only)?
Keep it short and to the point. 0.27. What is the ratio of the Gross enrolment ratio (%) in Pre-primary schools in Caribbean small states to that in Central Europe?
Provide a succinct answer. 1.06. What is the ratio of the Gross enrolment ratio (%) in Primary schools in Caribbean small states to that in Central Europe?
Ensure brevity in your answer.  1. What is the ratio of the Gross enrolment ratio (%) in Secondary schools in Caribbean small states to that in Central Europe?
Keep it short and to the point. 0.77. What is the ratio of the Gross enrolment ratio (%) in Tertiary schools in Caribbean small states to that in Central Europe?
Offer a very short reply. 0.38. What is the ratio of the Gross enrolment ratio (%) in Pre-primary schools in Caribbean small states to that in Euro area?
Keep it short and to the point. 0.74. What is the ratio of the Gross enrolment ratio (%) in Primary schools in Caribbean small states to that in Euro area?
Your response must be concise. 0.96. What is the ratio of the Gross enrolment ratio (%) of Secondary schools in Caribbean small states to that in Euro area?
Offer a very short reply. 1.45. What is the ratio of the Gross enrolment ratio (%) in Tertiary schools in Caribbean small states to that in Euro area?
Ensure brevity in your answer.  2.02. What is the ratio of the Gross enrolment ratio (%) in Pre-primary schools in Caribbean small states to that in Europe(all income levels)?
Your answer should be compact. 0.97. What is the ratio of the Gross enrolment ratio (%) of Primary schools in Caribbean small states to that in Europe(all income levels)?
Make the answer very short. 0.96. What is the ratio of the Gross enrolment ratio (%) of Secondary schools in Caribbean small states to that in Europe(all income levels)?
Your answer should be very brief. 1.63. What is the ratio of the Gross enrolment ratio (%) in Tertiary schools in Caribbean small states to that in Europe(all income levels)?
Your answer should be compact. 3.84. What is the ratio of the Gross enrolment ratio (%) of Pre-primary schools in Caribbean small states to that in Europe(developing only)?
Provide a short and direct response. 1.31. What is the ratio of the Gross enrolment ratio (%) of Primary schools in Caribbean small states to that in Europe(developing only)?
Provide a succinct answer. 0.98. What is the ratio of the Gross enrolment ratio (%) in Secondary schools in Caribbean small states to that in Europe(developing only)?
Offer a terse response. 0.77. What is the ratio of the Gross enrolment ratio (%) of Tertiary schools in Caribbean small states to that in Europe(developing only)?
Keep it short and to the point. 0.27. What is the ratio of the Gross enrolment ratio (%) of Pre-primary schools in Central Europe to that in Euro area?
Ensure brevity in your answer.  0.69. What is the ratio of the Gross enrolment ratio (%) of Primary schools in Central Europe to that in Euro area?
Make the answer very short. 0.97. What is the ratio of the Gross enrolment ratio (%) in Secondary schools in Central Europe to that in Euro area?
Offer a very short reply. 1.89. What is the ratio of the Gross enrolment ratio (%) in Tertiary schools in Central Europe to that in Euro area?
Offer a very short reply. 5.38. What is the ratio of the Gross enrolment ratio (%) of Pre-primary schools in Central Europe to that in Europe(all income levels)?
Offer a terse response. 0.91. What is the ratio of the Gross enrolment ratio (%) of Primary schools in Central Europe to that in Europe(all income levels)?
Ensure brevity in your answer.  0.96. What is the ratio of the Gross enrolment ratio (%) in Secondary schools in Central Europe to that in Europe(all income levels)?
Offer a very short reply. 2.12. What is the ratio of the Gross enrolment ratio (%) of Tertiary schools in Central Europe to that in Europe(all income levels)?
Your answer should be very brief. 10.21. What is the ratio of the Gross enrolment ratio (%) of Pre-primary schools in Central Europe to that in Europe(developing only)?
Provide a succinct answer. 1.24. What is the ratio of the Gross enrolment ratio (%) of Primary schools in Central Europe to that in Europe(developing only)?
Offer a terse response. 0.99. What is the ratio of the Gross enrolment ratio (%) in Tertiary schools in Central Europe to that in Europe(developing only)?
Keep it short and to the point. 0.73. What is the ratio of the Gross enrolment ratio (%) of Pre-primary schools in Euro area to that in Europe(all income levels)?
Your answer should be very brief. 1.32. What is the ratio of the Gross enrolment ratio (%) of Primary schools in Euro area to that in Europe(all income levels)?
Your answer should be compact. 0.99. What is the ratio of the Gross enrolment ratio (%) in Secondary schools in Euro area to that in Europe(all income levels)?
Give a very brief answer. 1.12. What is the ratio of the Gross enrolment ratio (%) in Tertiary schools in Euro area to that in Europe(all income levels)?
Provide a short and direct response. 1.9. What is the ratio of the Gross enrolment ratio (%) of Pre-primary schools in Euro area to that in Europe(developing only)?
Your answer should be compact. 1.79. What is the ratio of the Gross enrolment ratio (%) in Primary schools in Euro area to that in Europe(developing only)?
Your response must be concise. 1.02. What is the ratio of the Gross enrolment ratio (%) of Secondary schools in Euro area to that in Europe(developing only)?
Provide a succinct answer. 0.53. What is the ratio of the Gross enrolment ratio (%) of Tertiary schools in Euro area to that in Europe(developing only)?
Keep it short and to the point. 0.14. What is the ratio of the Gross enrolment ratio (%) of Pre-primary schools in Europe(all income levels) to that in Europe(developing only)?
Your response must be concise. 1.36. What is the ratio of the Gross enrolment ratio (%) in Primary schools in Europe(all income levels) to that in Europe(developing only)?
Provide a succinct answer. 1.03. What is the ratio of the Gross enrolment ratio (%) of Secondary schools in Europe(all income levels) to that in Europe(developing only)?
Offer a terse response. 0.47. What is the ratio of the Gross enrolment ratio (%) in Tertiary schools in Europe(all income levels) to that in Europe(developing only)?
Give a very brief answer. 0.07. What is the difference between the highest and the second highest Gross enrolment ratio (%) in Pre-primary schools?
Your answer should be compact. 18.23. What is the difference between the highest and the second highest Gross enrolment ratio (%) of Primary schools?
Your response must be concise. 0.55. What is the difference between the highest and the second highest Gross enrolment ratio (%) in Secondary schools?
Offer a very short reply. 0.03. What is the difference between the highest and the second highest Gross enrolment ratio (%) in Tertiary schools?
Provide a succinct answer. 5.77. What is the difference between the highest and the lowest Gross enrolment ratio (%) of Pre-primary schools?
Your answer should be compact. 67.59. What is the difference between the highest and the lowest Gross enrolment ratio (%) of Primary schools?
Offer a terse response. 50.05. What is the difference between the highest and the lowest Gross enrolment ratio (%) of Secondary schools?
Keep it short and to the point. 60. What is the difference between the highest and the lowest Gross enrolment ratio (%) of Tertiary schools?
Offer a very short reply. 19.74. 